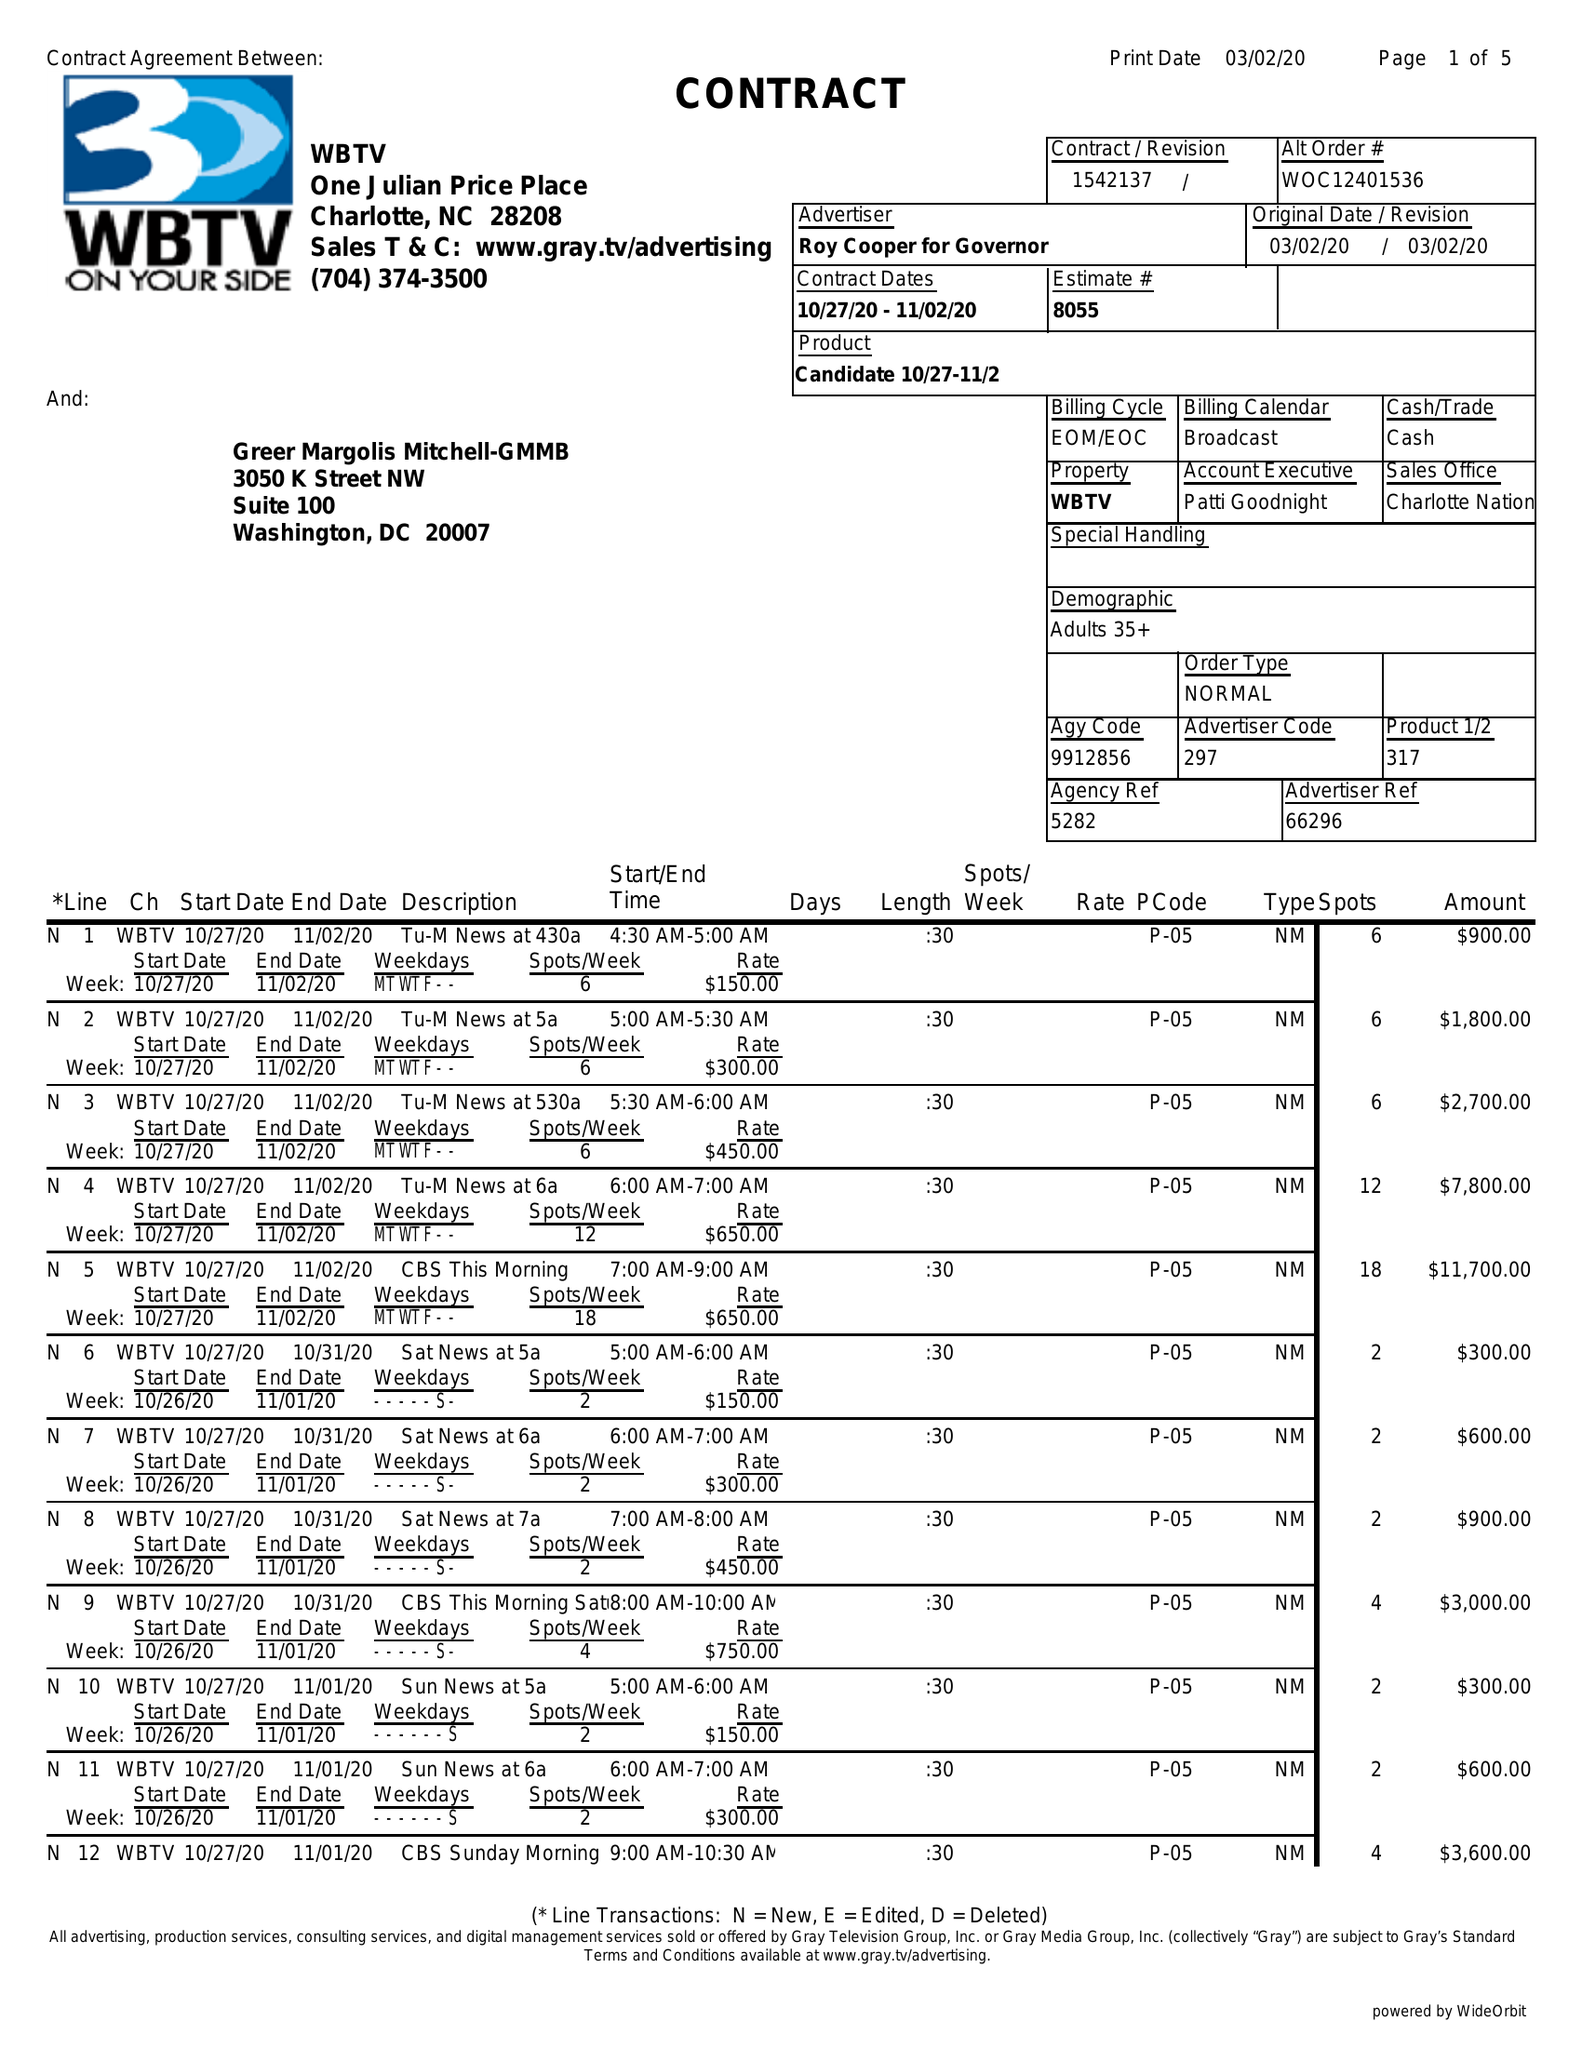What is the value for the contract_num?
Answer the question using a single word or phrase. 1542137 